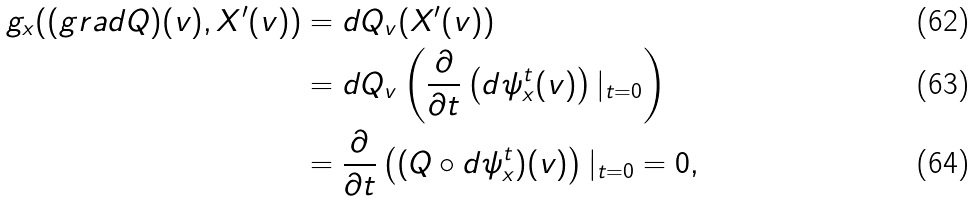Convert formula to latex. <formula><loc_0><loc_0><loc_500><loc_500>g _ { x } ( ( g r a d Q ) ( v ) , X ^ { \prime } ( v ) ) & = d Q _ { v } ( X ^ { \prime } ( v ) ) \\ & = d Q _ { v } \left ( \frac { \partial } { \partial t } \left ( d \psi _ { x } ^ { t } ( v ) \right ) | _ { t = 0 } \right ) \\ & = \frac { \partial } { \partial t } \left ( ( Q \circ d \psi _ { x } ^ { t } ) ( v ) \right ) | _ { t = 0 } = 0 ,</formula> 